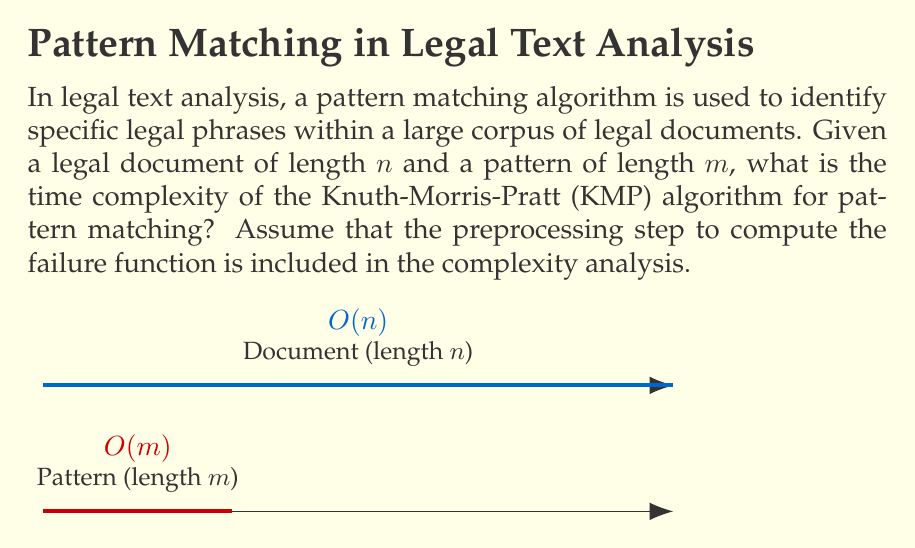Give your solution to this math problem. To analyze the time complexity of the Knuth-Morris-Pratt (KMP) algorithm for pattern matching in legal text analysis, we need to consider two main steps:

1. Preprocessing step (computing the failure function):
   - This step takes $O(m)$ time, where $m$ is the length of the pattern.
   - The failure function is computed once for the pattern and can be reused for multiple searches.

2. Matching step:
   - The KMP algorithm processes the document once, comparing each character with the pattern.
   - In the worst case, it examines each character of the document exactly once.
   - This step takes $O(n)$ time, where $n$ is the length of the document.

The total time complexity is the sum of these two steps:

$$ T(n, m) = O(m) + O(n) $$

Since we're dealing with asymptotic notation, we can simplify this to:

$$ T(n, m) = O(n + m) $$

In most practical cases for legal text analysis, the document length $n$ is much larger than the pattern length $m$. Therefore, we can further simplify the complexity to $O(n)$.

However, it's important to note that in the formal analysis, we keep both terms to account for cases where the pattern might be comparatively large.
Answer: $O(n + m)$ 